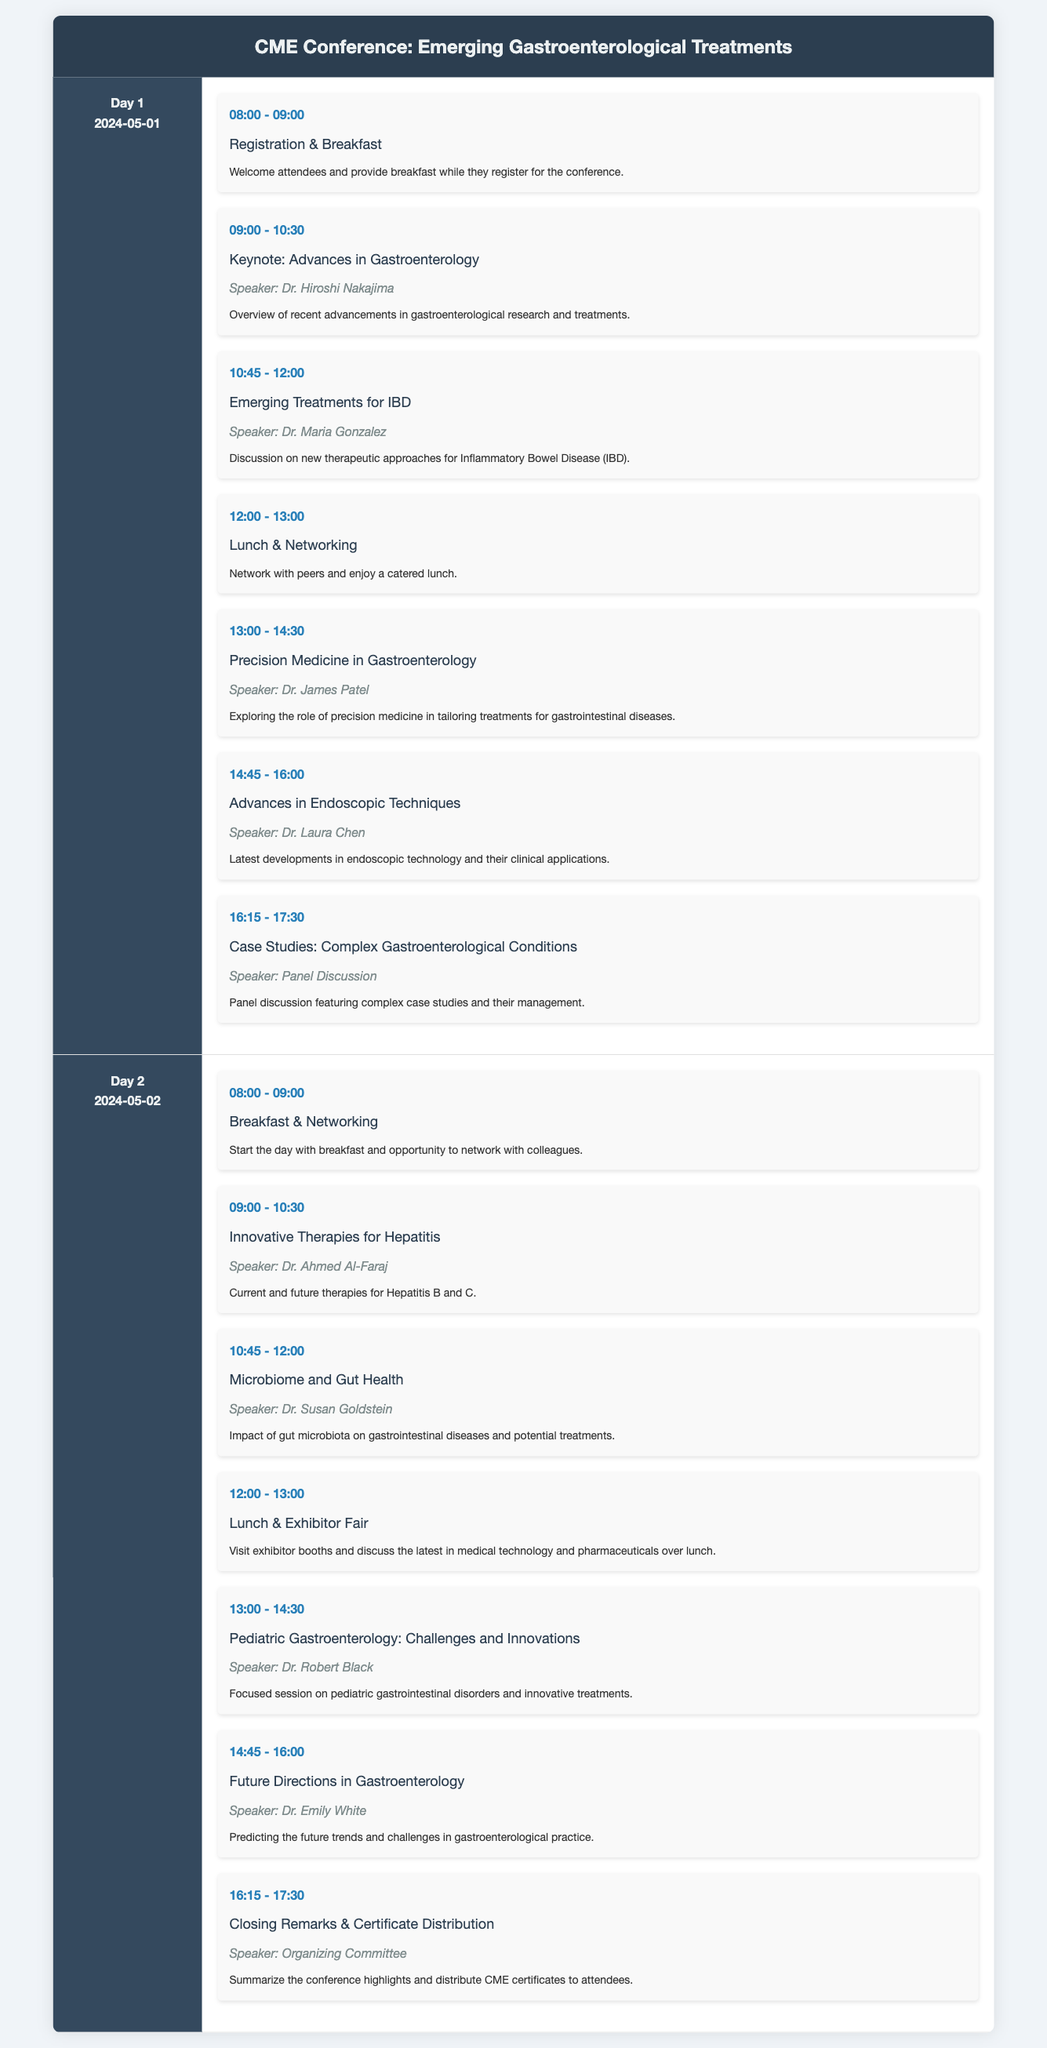what is the date of Day 1? Day 1 of the conference is scheduled for May 1, 2024.
Answer: 2024-05-01 who is the speaker for the session on Emerging Treatments for IBD? The session on Emerging Treatments for IBD is led by Dr. Maria Gonzalez.
Answer: Dr. Maria Gonzalez what time does the keynote session start? The keynote session begins at 09:00 AM on Day 1.
Answer: 09:00 how many sessions are there on Day 2? There are seven sessions scheduled on Day 2 of the conference.
Answer: 7 which topic is covered by Dr. Ahmed Al-Faraj? Dr. Ahmed Al-Faraj covers Innovative Therapies for Hepatitis.
Answer: Innovative Therapies for Hepatitis what is the purpose of the Lunch & Networking session on Day 1? The Lunch & Networking session allows attendees to network with peers while enjoying a catered lunch.
Answer: Network with peers what is the final activity on Day 2? The final activity on Day 2 is the Closing Remarks & Certificate Distribution.
Answer: Closing Remarks & Certificate Distribution who discusses the challenges in Pediatric Gastroenterology? Dr. Robert Black is the speaker focusing on challenges and innovations in Pediatric Gastroenterology.
Answer: Dr. Robert Black 